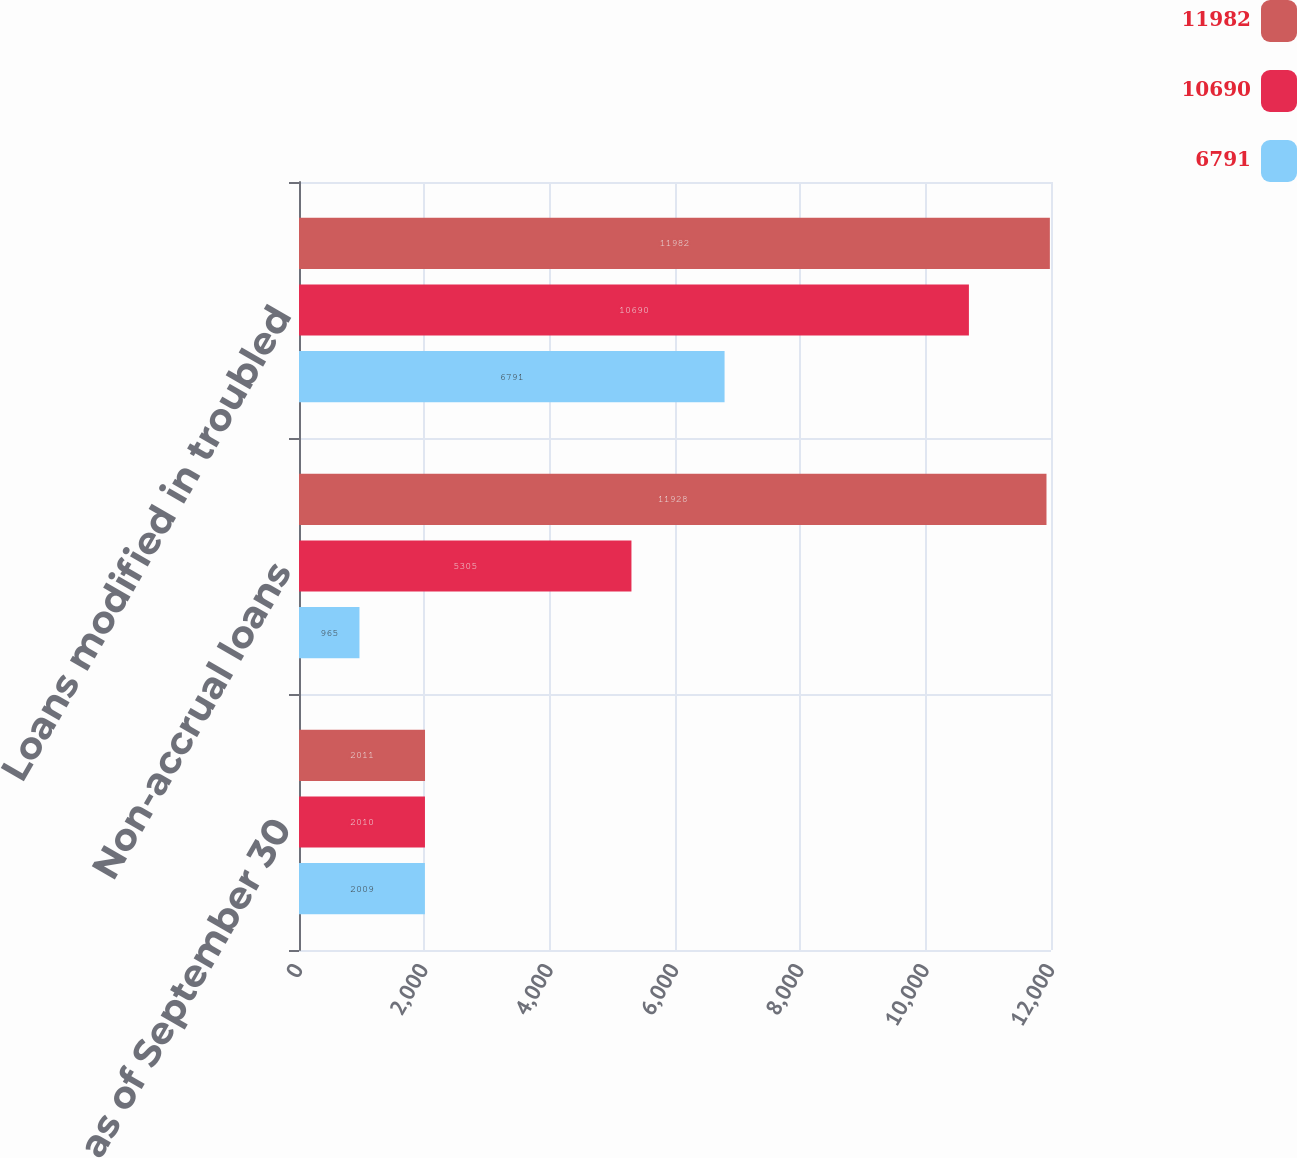Convert chart. <chart><loc_0><loc_0><loc_500><loc_500><stacked_bar_chart><ecel><fcel>as of September 30<fcel>Non-accrual loans<fcel>Loans modified in troubled<nl><fcel>11982<fcel>2011<fcel>11928<fcel>11982<nl><fcel>10690<fcel>2010<fcel>5305<fcel>10690<nl><fcel>6791<fcel>2009<fcel>965<fcel>6791<nl></chart> 